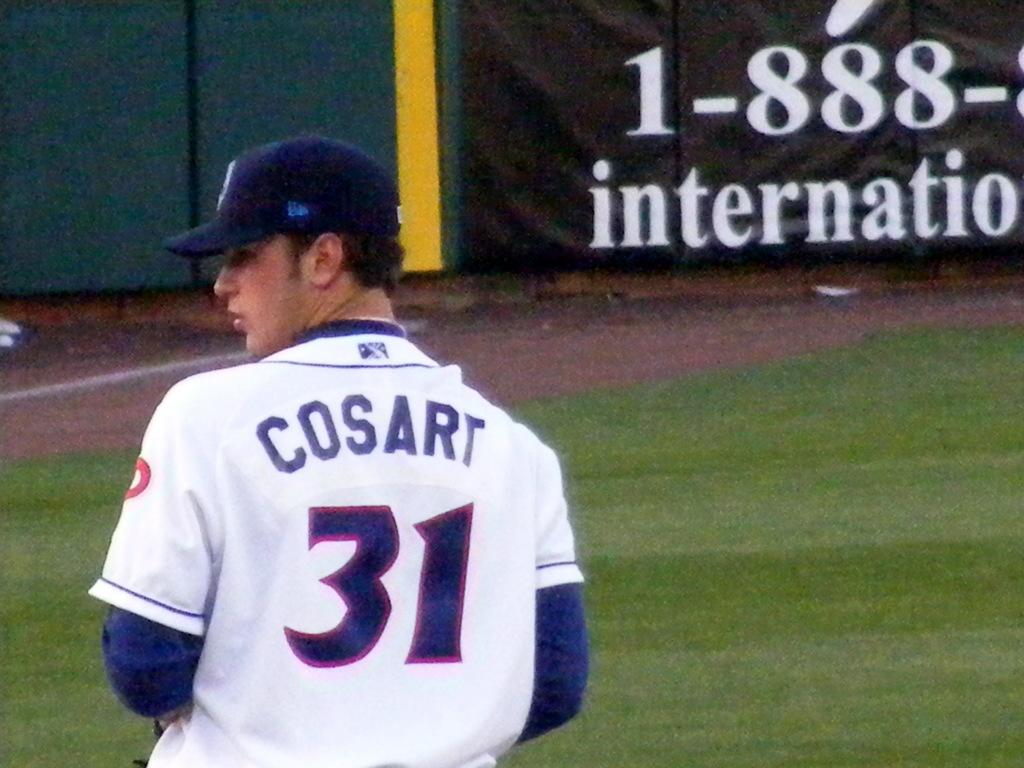<image>
Give a short and clear explanation of the subsequent image. Baseball player Cosart is on the field looking for the next play. 